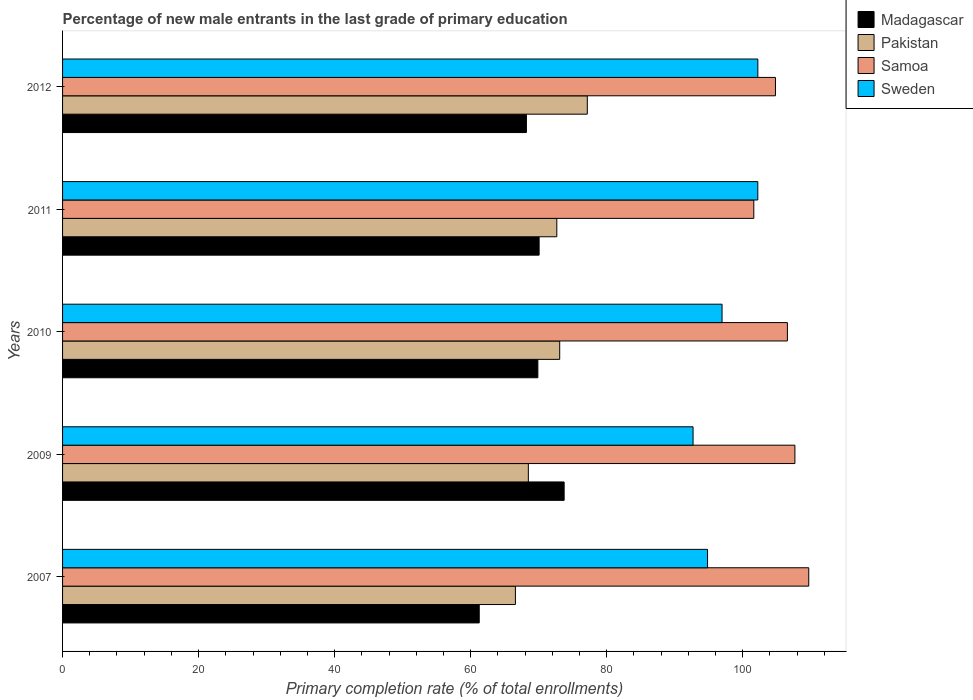How many different coloured bars are there?
Your answer should be compact. 4. How many groups of bars are there?
Ensure brevity in your answer.  5. Are the number of bars on each tick of the Y-axis equal?
Ensure brevity in your answer.  Yes. How many bars are there on the 2nd tick from the top?
Keep it short and to the point. 4. What is the percentage of new male entrants in Madagascar in 2011?
Offer a terse response. 70.07. Across all years, what is the maximum percentage of new male entrants in Pakistan?
Ensure brevity in your answer.  77.15. Across all years, what is the minimum percentage of new male entrants in Sweden?
Give a very brief answer. 92.7. In which year was the percentage of new male entrants in Madagascar maximum?
Your response must be concise. 2009. What is the total percentage of new male entrants in Sweden in the graph?
Your answer should be very brief. 488.94. What is the difference between the percentage of new male entrants in Madagascar in 2009 and that in 2011?
Ensure brevity in your answer.  3.68. What is the difference between the percentage of new male entrants in Sweden in 2010 and the percentage of new male entrants in Pakistan in 2009?
Ensure brevity in your answer.  28.48. What is the average percentage of new male entrants in Sweden per year?
Your answer should be compact. 97.79. In the year 2009, what is the difference between the percentage of new male entrants in Samoa and percentage of new male entrants in Sweden?
Your answer should be compact. 14.97. What is the ratio of the percentage of new male entrants in Samoa in 2007 to that in 2012?
Ensure brevity in your answer.  1.05. Is the difference between the percentage of new male entrants in Samoa in 2010 and 2011 greater than the difference between the percentage of new male entrants in Sweden in 2010 and 2011?
Your answer should be very brief. Yes. What is the difference between the highest and the second highest percentage of new male entrants in Sweden?
Give a very brief answer. 0.01. What is the difference between the highest and the lowest percentage of new male entrants in Pakistan?
Provide a short and direct response. 10.57. In how many years, is the percentage of new male entrants in Pakistan greater than the average percentage of new male entrants in Pakistan taken over all years?
Your answer should be very brief. 3. What does the 4th bar from the top in 2010 represents?
Your answer should be very brief. Madagascar. What does the 4th bar from the bottom in 2007 represents?
Give a very brief answer. Sweden. Is it the case that in every year, the sum of the percentage of new male entrants in Madagascar and percentage of new male entrants in Pakistan is greater than the percentage of new male entrants in Samoa?
Ensure brevity in your answer.  Yes. How many bars are there?
Your response must be concise. 20. What is the difference between two consecutive major ticks on the X-axis?
Keep it short and to the point. 20. Does the graph contain grids?
Keep it short and to the point. No. What is the title of the graph?
Provide a succinct answer. Percentage of new male entrants in the last grade of primary education. What is the label or title of the X-axis?
Provide a succinct answer. Primary completion rate (% of total enrollments). What is the label or title of the Y-axis?
Give a very brief answer. Years. What is the Primary completion rate (% of total enrollments) in Madagascar in 2007?
Your response must be concise. 61.26. What is the Primary completion rate (% of total enrollments) in Pakistan in 2007?
Provide a short and direct response. 66.58. What is the Primary completion rate (% of total enrollments) of Samoa in 2007?
Your response must be concise. 109.71. What is the Primary completion rate (% of total enrollments) of Sweden in 2007?
Your answer should be compact. 94.83. What is the Primary completion rate (% of total enrollments) in Madagascar in 2009?
Keep it short and to the point. 73.75. What is the Primary completion rate (% of total enrollments) in Pakistan in 2009?
Provide a short and direct response. 68.48. What is the Primary completion rate (% of total enrollments) of Samoa in 2009?
Ensure brevity in your answer.  107.68. What is the Primary completion rate (% of total enrollments) of Sweden in 2009?
Make the answer very short. 92.7. What is the Primary completion rate (% of total enrollments) of Madagascar in 2010?
Provide a succinct answer. 69.88. What is the Primary completion rate (% of total enrollments) in Pakistan in 2010?
Give a very brief answer. 73.09. What is the Primary completion rate (% of total enrollments) in Samoa in 2010?
Make the answer very short. 106.57. What is the Primary completion rate (% of total enrollments) of Sweden in 2010?
Offer a very short reply. 96.96. What is the Primary completion rate (% of total enrollments) in Madagascar in 2011?
Make the answer very short. 70.07. What is the Primary completion rate (% of total enrollments) of Pakistan in 2011?
Make the answer very short. 72.67. What is the Primary completion rate (% of total enrollments) of Samoa in 2011?
Keep it short and to the point. 101.63. What is the Primary completion rate (% of total enrollments) of Sweden in 2011?
Your answer should be compact. 102.22. What is the Primary completion rate (% of total enrollments) of Madagascar in 2012?
Your answer should be compact. 68.2. What is the Primary completion rate (% of total enrollments) in Pakistan in 2012?
Ensure brevity in your answer.  77.15. What is the Primary completion rate (% of total enrollments) of Samoa in 2012?
Keep it short and to the point. 104.82. What is the Primary completion rate (% of total enrollments) in Sweden in 2012?
Offer a terse response. 102.23. Across all years, what is the maximum Primary completion rate (% of total enrollments) in Madagascar?
Your answer should be very brief. 73.75. Across all years, what is the maximum Primary completion rate (% of total enrollments) of Pakistan?
Ensure brevity in your answer.  77.15. Across all years, what is the maximum Primary completion rate (% of total enrollments) in Samoa?
Make the answer very short. 109.71. Across all years, what is the maximum Primary completion rate (% of total enrollments) of Sweden?
Your answer should be compact. 102.23. Across all years, what is the minimum Primary completion rate (% of total enrollments) in Madagascar?
Your answer should be very brief. 61.26. Across all years, what is the minimum Primary completion rate (% of total enrollments) of Pakistan?
Make the answer very short. 66.58. Across all years, what is the minimum Primary completion rate (% of total enrollments) in Samoa?
Offer a very short reply. 101.63. Across all years, what is the minimum Primary completion rate (% of total enrollments) of Sweden?
Offer a terse response. 92.7. What is the total Primary completion rate (% of total enrollments) in Madagascar in the graph?
Your answer should be compact. 343.16. What is the total Primary completion rate (% of total enrollments) of Pakistan in the graph?
Give a very brief answer. 357.97. What is the total Primary completion rate (% of total enrollments) in Samoa in the graph?
Your response must be concise. 530.4. What is the total Primary completion rate (% of total enrollments) in Sweden in the graph?
Provide a succinct answer. 488.94. What is the difference between the Primary completion rate (% of total enrollments) of Madagascar in 2007 and that in 2009?
Make the answer very short. -12.48. What is the difference between the Primary completion rate (% of total enrollments) of Pakistan in 2007 and that in 2009?
Offer a terse response. -1.9. What is the difference between the Primary completion rate (% of total enrollments) of Samoa in 2007 and that in 2009?
Your response must be concise. 2.03. What is the difference between the Primary completion rate (% of total enrollments) in Sweden in 2007 and that in 2009?
Make the answer very short. 2.13. What is the difference between the Primary completion rate (% of total enrollments) of Madagascar in 2007 and that in 2010?
Give a very brief answer. -8.62. What is the difference between the Primary completion rate (% of total enrollments) of Pakistan in 2007 and that in 2010?
Offer a very short reply. -6.51. What is the difference between the Primary completion rate (% of total enrollments) in Samoa in 2007 and that in 2010?
Your response must be concise. 3.14. What is the difference between the Primary completion rate (% of total enrollments) in Sweden in 2007 and that in 2010?
Keep it short and to the point. -2.13. What is the difference between the Primary completion rate (% of total enrollments) in Madagascar in 2007 and that in 2011?
Give a very brief answer. -8.8. What is the difference between the Primary completion rate (% of total enrollments) in Pakistan in 2007 and that in 2011?
Your answer should be compact. -6.09. What is the difference between the Primary completion rate (% of total enrollments) in Samoa in 2007 and that in 2011?
Provide a succinct answer. 8.08. What is the difference between the Primary completion rate (% of total enrollments) in Sweden in 2007 and that in 2011?
Your response must be concise. -7.39. What is the difference between the Primary completion rate (% of total enrollments) in Madagascar in 2007 and that in 2012?
Ensure brevity in your answer.  -6.94. What is the difference between the Primary completion rate (% of total enrollments) of Pakistan in 2007 and that in 2012?
Offer a very short reply. -10.57. What is the difference between the Primary completion rate (% of total enrollments) in Samoa in 2007 and that in 2012?
Offer a terse response. 4.89. What is the difference between the Primary completion rate (% of total enrollments) of Sweden in 2007 and that in 2012?
Offer a terse response. -7.4. What is the difference between the Primary completion rate (% of total enrollments) of Madagascar in 2009 and that in 2010?
Your answer should be compact. 3.87. What is the difference between the Primary completion rate (% of total enrollments) of Pakistan in 2009 and that in 2010?
Ensure brevity in your answer.  -4.61. What is the difference between the Primary completion rate (% of total enrollments) in Samoa in 2009 and that in 2010?
Your answer should be very brief. 1.1. What is the difference between the Primary completion rate (% of total enrollments) of Sweden in 2009 and that in 2010?
Provide a succinct answer. -4.26. What is the difference between the Primary completion rate (% of total enrollments) of Madagascar in 2009 and that in 2011?
Your answer should be very brief. 3.68. What is the difference between the Primary completion rate (% of total enrollments) of Pakistan in 2009 and that in 2011?
Provide a short and direct response. -4.18. What is the difference between the Primary completion rate (% of total enrollments) of Samoa in 2009 and that in 2011?
Offer a very short reply. 6.05. What is the difference between the Primary completion rate (% of total enrollments) of Sweden in 2009 and that in 2011?
Keep it short and to the point. -9.52. What is the difference between the Primary completion rate (% of total enrollments) of Madagascar in 2009 and that in 2012?
Provide a short and direct response. 5.55. What is the difference between the Primary completion rate (% of total enrollments) of Pakistan in 2009 and that in 2012?
Provide a short and direct response. -8.67. What is the difference between the Primary completion rate (% of total enrollments) of Samoa in 2009 and that in 2012?
Your answer should be very brief. 2.86. What is the difference between the Primary completion rate (% of total enrollments) in Sweden in 2009 and that in 2012?
Keep it short and to the point. -9.52. What is the difference between the Primary completion rate (% of total enrollments) of Madagascar in 2010 and that in 2011?
Provide a succinct answer. -0.19. What is the difference between the Primary completion rate (% of total enrollments) in Pakistan in 2010 and that in 2011?
Your response must be concise. 0.43. What is the difference between the Primary completion rate (% of total enrollments) in Samoa in 2010 and that in 2011?
Your answer should be very brief. 4.94. What is the difference between the Primary completion rate (% of total enrollments) of Sweden in 2010 and that in 2011?
Keep it short and to the point. -5.26. What is the difference between the Primary completion rate (% of total enrollments) in Madagascar in 2010 and that in 2012?
Offer a very short reply. 1.68. What is the difference between the Primary completion rate (% of total enrollments) of Pakistan in 2010 and that in 2012?
Provide a short and direct response. -4.06. What is the difference between the Primary completion rate (% of total enrollments) in Samoa in 2010 and that in 2012?
Your response must be concise. 1.76. What is the difference between the Primary completion rate (% of total enrollments) in Sweden in 2010 and that in 2012?
Your answer should be compact. -5.26. What is the difference between the Primary completion rate (% of total enrollments) of Madagascar in 2011 and that in 2012?
Give a very brief answer. 1.87. What is the difference between the Primary completion rate (% of total enrollments) in Pakistan in 2011 and that in 2012?
Your answer should be compact. -4.48. What is the difference between the Primary completion rate (% of total enrollments) of Samoa in 2011 and that in 2012?
Provide a short and direct response. -3.18. What is the difference between the Primary completion rate (% of total enrollments) in Sweden in 2011 and that in 2012?
Your answer should be compact. -0.01. What is the difference between the Primary completion rate (% of total enrollments) in Madagascar in 2007 and the Primary completion rate (% of total enrollments) in Pakistan in 2009?
Provide a succinct answer. -7.22. What is the difference between the Primary completion rate (% of total enrollments) of Madagascar in 2007 and the Primary completion rate (% of total enrollments) of Samoa in 2009?
Ensure brevity in your answer.  -46.41. What is the difference between the Primary completion rate (% of total enrollments) of Madagascar in 2007 and the Primary completion rate (% of total enrollments) of Sweden in 2009?
Offer a very short reply. -31.44. What is the difference between the Primary completion rate (% of total enrollments) in Pakistan in 2007 and the Primary completion rate (% of total enrollments) in Samoa in 2009?
Give a very brief answer. -41.1. What is the difference between the Primary completion rate (% of total enrollments) of Pakistan in 2007 and the Primary completion rate (% of total enrollments) of Sweden in 2009?
Provide a short and direct response. -26.12. What is the difference between the Primary completion rate (% of total enrollments) of Samoa in 2007 and the Primary completion rate (% of total enrollments) of Sweden in 2009?
Your answer should be compact. 17.01. What is the difference between the Primary completion rate (% of total enrollments) of Madagascar in 2007 and the Primary completion rate (% of total enrollments) of Pakistan in 2010?
Give a very brief answer. -11.83. What is the difference between the Primary completion rate (% of total enrollments) of Madagascar in 2007 and the Primary completion rate (% of total enrollments) of Samoa in 2010?
Provide a succinct answer. -45.31. What is the difference between the Primary completion rate (% of total enrollments) in Madagascar in 2007 and the Primary completion rate (% of total enrollments) in Sweden in 2010?
Your answer should be compact. -35.7. What is the difference between the Primary completion rate (% of total enrollments) in Pakistan in 2007 and the Primary completion rate (% of total enrollments) in Samoa in 2010?
Provide a short and direct response. -39.99. What is the difference between the Primary completion rate (% of total enrollments) in Pakistan in 2007 and the Primary completion rate (% of total enrollments) in Sweden in 2010?
Keep it short and to the point. -30.38. What is the difference between the Primary completion rate (% of total enrollments) in Samoa in 2007 and the Primary completion rate (% of total enrollments) in Sweden in 2010?
Provide a short and direct response. 12.75. What is the difference between the Primary completion rate (% of total enrollments) in Madagascar in 2007 and the Primary completion rate (% of total enrollments) in Pakistan in 2011?
Your answer should be very brief. -11.41. What is the difference between the Primary completion rate (% of total enrollments) in Madagascar in 2007 and the Primary completion rate (% of total enrollments) in Samoa in 2011?
Provide a short and direct response. -40.37. What is the difference between the Primary completion rate (% of total enrollments) in Madagascar in 2007 and the Primary completion rate (% of total enrollments) in Sweden in 2011?
Your response must be concise. -40.96. What is the difference between the Primary completion rate (% of total enrollments) in Pakistan in 2007 and the Primary completion rate (% of total enrollments) in Samoa in 2011?
Give a very brief answer. -35.05. What is the difference between the Primary completion rate (% of total enrollments) in Pakistan in 2007 and the Primary completion rate (% of total enrollments) in Sweden in 2011?
Your response must be concise. -35.64. What is the difference between the Primary completion rate (% of total enrollments) of Samoa in 2007 and the Primary completion rate (% of total enrollments) of Sweden in 2011?
Ensure brevity in your answer.  7.49. What is the difference between the Primary completion rate (% of total enrollments) in Madagascar in 2007 and the Primary completion rate (% of total enrollments) in Pakistan in 2012?
Your answer should be compact. -15.89. What is the difference between the Primary completion rate (% of total enrollments) in Madagascar in 2007 and the Primary completion rate (% of total enrollments) in Samoa in 2012?
Offer a very short reply. -43.55. What is the difference between the Primary completion rate (% of total enrollments) of Madagascar in 2007 and the Primary completion rate (% of total enrollments) of Sweden in 2012?
Provide a short and direct response. -40.96. What is the difference between the Primary completion rate (% of total enrollments) of Pakistan in 2007 and the Primary completion rate (% of total enrollments) of Samoa in 2012?
Keep it short and to the point. -38.23. What is the difference between the Primary completion rate (% of total enrollments) in Pakistan in 2007 and the Primary completion rate (% of total enrollments) in Sweden in 2012?
Keep it short and to the point. -35.65. What is the difference between the Primary completion rate (% of total enrollments) in Samoa in 2007 and the Primary completion rate (% of total enrollments) in Sweden in 2012?
Your response must be concise. 7.48. What is the difference between the Primary completion rate (% of total enrollments) in Madagascar in 2009 and the Primary completion rate (% of total enrollments) in Pakistan in 2010?
Provide a short and direct response. 0.65. What is the difference between the Primary completion rate (% of total enrollments) in Madagascar in 2009 and the Primary completion rate (% of total enrollments) in Samoa in 2010?
Give a very brief answer. -32.83. What is the difference between the Primary completion rate (% of total enrollments) in Madagascar in 2009 and the Primary completion rate (% of total enrollments) in Sweden in 2010?
Give a very brief answer. -23.22. What is the difference between the Primary completion rate (% of total enrollments) in Pakistan in 2009 and the Primary completion rate (% of total enrollments) in Samoa in 2010?
Ensure brevity in your answer.  -38.09. What is the difference between the Primary completion rate (% of total enrollments) of Pakistan in 2009 and the Primary completion rate (% of total enrollments) of Sweden in 2010?
Offer a very short reply. -28.48. What is the difference between the Primary completion rate (% of total enrollments) in Samoa in 2009 and the Primary completion rate (% of total enrollments) in Sweden in 2010?
Ensure brevity in your answer.  10.71. What is the difference between the Primary completion rate (% of total enrollments) in Madagascar in 2009 and the Primary completion rate (% of total enrollments) in Pakistan in 2011?
Your answer should be compact. 1.08. What is the difference between the Primary completion rate (% of total enrollments) of Madagascar in 2009 and the Primary completion rate (% of total enrollments) of Samoa in 2011?
Make the answer very short. -27.88. What is the difference between the Primary completion rate (% of total enrollments) of Madagascar in 2009 and the Primary completion rate (% of total enrollments) of Sweden in 2011?
Offer a very short reply. -28.47. What is the difference between the Primary completion rate (% of total enrollments) in Pakistan in 2009 and the Primary completion rate (% of total enrollments) in Samoa in 2011?
Keep it short and to the point. -33.15. What is the difference between the Primary completion rate (% of total enrollments) in Pakistan in 2009 and the Primary completion rate (% of total enrollments) in Sweden in 2011?
Ensure brevity in your answer.  -33.74. What is the difference between the Primary completion rate (% of total enrollments) of Samoa in 2009 and the Primary completion rate (% of total enrollments) of Sweden in 2011?
Ensure brevity in your answer.  5.46. What is the difference between the Primary completion rate (% of total enrollments) of Madagascar in 2009 and the Primary completion rate (% of total enrollments) of Pakistan in 2012?
Offer a very short reply. -3.4. What is the difference between the Primary completion rate (% of total enrollments) of Madagascar in 2009 and the Primary completion rate (% of total enrollments) of Samoa in 2012?
Offer a terse response. -31.07. What is the difference between the Primary completion rate (% of total enrollments) in Madagascar in 2009 and the Primary completion rate (% of total enrollments) in Sweden in 2012?
Provide a succinct answer. -28.48. What is the difference between the Primary completion rate (% of total enrollments) of Pakistan in 2009 and the Primary completion rate (% of total enrollments) of Samoa in 2012?
Keep it short and to the point. -36.33. What is the difference between the Primary completion rate (% of total enrollments) in Pakistan in 2009 and the Primary completion rate (% of total enrollments) in Sweden in 2012?
Ensure brevity in your answer.  -33.74. What is the difference between the Primary completion rate (% of total enrollments) of Samoa in 2009 and the Primary completion rate (% of total enrollments) of Sweden in 2012?
Offer a very short reply. 5.45. What is the difference between the Primary completion rate (% of total enrollments) in Madagascar in 2010 and the Primary completion rate (% of total enrollments) in Pakistan in 2011?
Make the answer very short. -2.79. What is the difference between the Primary completion rate (% of total enrollments) in Madagascar in 2010 and the Primary completion rate (% of total enrollments) in Samoa in 2011?
Provide a succinct answer. -31.75. What is the difference between the Primary completion rate (% of total enrollments) in Madagascar in 2010 and the Primary completion rate (% of total enrollments) in Sweden in 2011?
Give a very brief answer. -32.34. What is the difference between the Primary completion rate (% of total enrollments) in Pakistan in 2010 and the Primary completion rate (% of total enrollments) in Samoa in 2011?
Provide a succinct answer. -28.54. What is the difference between the Primary completion rate (% of total enrollments) of Pakistan in 2010 and the Primary completion rate (% of total enrollments) of Sweden in 2011?
Your answer should be very brief. -29.13. What is the difference between the Primary completion rate (% of total enrollments) of Samoa in 2010 and the Primary completion rate (% of total enrollments) of Sweden in 2011?
Your response must be concise. 4.35. What is the difference between the Primary completion rate (% of total enrollments) in Madagascar in 2010 and the Primary completion rate (% of total enrollments) in Pakistan in 2012?
Your answer should be compact. -7.27. What is the difference between the Primary completion rate (% of total enrollments) of Madagascar in 2010 and the Primary completion rate (% of total enrollments) of Samoa in 2012?
Your response must be concise. -34.93. What is the difference between the Primary completion rate (% of total enrollments) of Madagascar in 2010 and the Primary completion rate (% of total enrollments) of Sweden in 2012?
Offer a terse response. -32.35. What is the difference between the Primary completion rate (% of total enrollments) in Pakistan in 2010 and the Primary completion rate (% of total enrollments) in Samoa in 2012?
Keep it short and to the point. -31.72. What is the difference between the Primary completion rate (% of total enrollments) of Pakistan in 2010 and the Primary completion rate (% of total enrollments) of Sweden in 2012?
Your answer should be compact. -29.13. What is the difference between the Primary completion rate (% of total enrollments) in Samoa in 2010 and the Primary completion rate (% of total enrollments) in Sweden in 2012?
Provide a short and direct response. 4.35. What is the difference between the Primary completion rate (% of total enrollments) in Madagascar in 2011 and the Primary completion rate (% of total enrollments) in Pakistan in 2012?
Provide a succinct answer. -7.08. What is the difference between the Primary completion rate (% of total enrollments) of Madagascar in 2011 and the Primary completion rate (% of total enrollments) of Samoa in 2012?
Ensure brevity in your answer.  -34.75. What is the difference between the Primary completion rate (% of total enrollments) of Madagascar in 2011 and the Primary completion rate (% of total enrollments) of Sweden in 2012?
Give a very brief answer. -32.16. What is the difference between the Primary completion rate (% of total enrollments) of Pakistan in 2011 and the Primary completion rate (% of total enrollments) of Samoa in 2012?
Provide a short and direct response. -32.15. What is the difference between the Primary completion rate (% of total enrollments) in Pakistan in 2011 and the Primary completion rate (% of total enrollments) in Sweden in 2012?
Ensure brevity in your answer.  -29.56. What is the difference between the Primary completion rate (% of total enrollments) of Samoa in 2011 and the Primary completion rate (% of total enrollments) of Sweden in 2012?
Give a very brief answer. -0.6. What is the average Primary completion rate (% of total enrollments) of Madagascar per year?
Your answer should be very brief. 68.63. What is the average Primary completion rate (% of total enrollments) of Pakistan per year?
Make the answer very short. 71.59. What is the average Primary completion rate (% of total enrollments) in Samoa per year?
Give a very brief answer. 106.08. What is the average Primary completion rate (% of total enrollments) in Sweden per year?
Provide a succinct answer. 97.79. In the year 2007, what is the difference between the Primary completion rate (% of total enrollments) in Madagascar and Primary completion rate (% of total enrollments) in Pakistan?
Make the answer very short. -5.32. In the year 2007, what is the difference between the Primary completion rate (% of total enrollments) of Madagascar and Primary completion rate (% of total enrollments) of Samoa?
Give a very brief answer. -48.45. In the year 2007, what is the difference between the Primary completion rate (% of total enrollments) of Madagascar and Primary completion rate (% of total enrollments) of Sweden?
Your answer should be very brief. -33.57. In the year 2007, what is the difference between the Primary completion rate (% of total enrollments) in Pakistan and Primary completion rate (% of total enrollments) in Samoa?
Your answer should be compact. -43.13. In the year 2007, what is the difference between the Primary completion rate (% of total enrollments) of Pakistan and Primary completion rate (% of total enrollments) of Sweden?
Give a very brief answer. -28.25. In the year 2007, what is the difference between the Primary completion rate (% of total enrollments) in Samoa and Primary completion rate (% of total enrollments) in Sweden?
Provide a succinct answer. 14.88. In the year 2009, what is the difference between the Primary completion rate (% of total enrollments) of Madagascar and Primary completion rate (% of total enrollments) of Pakistan?
Make the answer very short. 5.26. In the year 2009, what is the difference between the Primary completion rate (% of total enrollments) in Madagascar and Primary completion rate (% of total enrollments) in Samoa?
Keep it short and to the point. -33.93. In the year 2009, what is the difference between the Primary completion rate (% of total enrollments) in Madagascar and Primary completion rate (% of total enrollments) in Sweden?
Make the answer very short. -18.96. In the year 2009, what is the difference between the Primary completion rate (% of total enrollments) of Pakistan and Primary completion rate (% of total enrollments) of Samoa?
Provide a succinct answer. -39.19. In the year 2009, what is the difference between the Primary completion rate (% of total enrollments) in Pakistan and Primary completion rate (% of total enrollments) in Sweden?
Make the answer very short. -24.22. In the year 2009, what is the difference between the Primary completion rate (% of total enrollments) in Samoa and Primary completion rate (% of total enrollments) in Sweden?
Offer a very short reply. 14.97. In the year 2010, what is the difference between the Primary completion rate (% of total enrollments) of Madagascar and Primary completion rate (% of total enrollments) of Pakistan?
Make the answer very short. -3.21. In the year 2010, what is the difference between the Primary completion rate (% of total enrollments) in Madagascar and Primary completion rate (% of total enrollments) in Samoa?
Provide a succinct answer. -36.69. In the year 2010, what is the difference between the Primary completion rate (% of total enrollments) of Madagascar and Primary completion rate (% of total enrollments) of Sweden?
Give a very brief answer. -27.08. In the year 2010, what is the difference between the Primary completion rate (% of total enrollments) of Pakistan and Primary completion rate (% of total enrollments) of Samoa?
Provide a short and direct response. -33.48. In the year 2010, what is the difference between the Primary completion rate (% of total enrollments) of Pakistan and Primary completion rate (% of total enrollments) of Sweden?
Make the answer very short. -23.87. In the year 2010, what is the difference between the Primary completion rate (% of total enrollments) in Samoa and Primary completion rate (% of total enrollments) in Sweden?
Keep it short and to the point. 9.61. In the year 2011, what is the difference between the Primary completion rate (% of total enrollments) of Madagascar and Primary completion rate (% of total enrollments) of Pakistan?
Your answer should be very brief. -2.6. In the year 2011, what is the difference between the Primary completion rate (% of total enrollments) of Madagascar and Primary completion rate (% of total enrollments) of Samoa?
Offer a terse response. -31.56. In the year 2011, what is the difference between the Primary completion rate (% of total enrollments) of Madagascar and Primary completion rate (% of total enrollments) of Sweden?
Your response must be concise. -32.15. In the year 2011, what is the difference between the Primary completion rate (% of total enrollments) in Pakistan and Primary completion rate (% of total enrollments) in Samoa?
Ensure brevity in your answer.  -28.96. In the year 2011, what is the difference between the Primary completion rate (% of total enrollments) in Pakistan and Primary completion rate (% of total enrollments) in Sweden?
Your answer should be compact. -29.55. In the year 2011, what is the difference between the Primary completion rate (% of total enrollments) of Samoa and Primary completion rate (% of total enrollments) of Sweden?
Ensure brevity in your answer.  -0.59. In the year 2012, what is the difference between the Primary completion rate (% of total enrollments) in Madagascar and Primary completion rate (% of total enrollments) in Pakistan?
Keep it short and to the point. -8.95. In the year 2012, what is the difference between the Primary completion rate (% of total enrollments) of Madagascar and Primary completion rate (% of total enrollments) of Samoa?
Give a very brief answer. -36.61. In the year 2012, what is the difference between the Primary completion rate (% of total enrollments) in Madagascar and Primary completion rate (% of total enrollments) in Sweden?
Ensure brevity in your answer.  -34.03. In the year 2012, what is the difference between the Primary completion rate (% of total enrollments) in Pakistan and Primary completion rate (% of total enrollments) in Samoa?
Keep it short and to the point. -27.66. In the year 2012, what is the difference between the Primary completion rate (% of total enrollments) of Pakistan and Primary completion rate (% of total enrollments) of Sweden?
Offer a terse response. -25.08. In the year 2012, what is the difference between the Primary completion rate (% of total enrollments) in Samoa and Primary completion rate (% of total enrollments) in Sweden?
Your answer should be compact. 2.59. What is the ratio of the Primary completion rate (% of total enrollments) in Madagascar in 2007 to that in 2009?
Your answer should be very brief. 0.83. What is the ratio of the Primary completion rate (% of total enrollments) in Pakistan in 2007 to that in 2009?
Provide a succinct answer. 0.97. What is the ratio of the Primary completion rate (% of total enrollments) in Samoa in 2007 to that in 2009?
Offer a very short reply. 1.02. What is the ratio of the Primary completion rate (% of total enrollments) of Madagascar in 2007 to that in 2010?
Keep it short and to the point. 0.88. What is the ratio of the Primary completion rate (% of total enrollments) in Pakistan in 2007 to that in 2010?
Your response must be concise. 0.91. What is the ratio of the Primary completion rate (% of total enrollments) in Samoa in 2007 to that in 2010?
Make the answer very short. 1.03. What is the ratio of the Primary completion rate (% of total enrollments) of Madagascar in 2007 to that in 2011?
Your answer should be very brief. 0.87. What is the ratio of the Primary completion rate (% of total enrollments) in Pakistan in 2007 to that in 2011?
Provide a short and direct response. 0.92. What is the ratio of the Primary completion rate (% of total enrollments) of Samoa in 2007 to that in 2011?
Provide a succinct answer. 1.08. What is the ratio of the Primary completion rate (% of total enrollments) in Sweden in 2007 to that in 2011?
Offer a very short reply. 0.93. What is the ratio of the Primary completion rate (% of total enrollments) of Madagascar in 2007 to that in 2012?
Your response must be concise. 0.9. What is the ratio of the Primary completion rate (% of total enrollments) in Pakistan in 2007 to that in 2012?
Your answer should be very brief. 0.86. What is the ratio of the Primary completion rate (% of total enrollments) of Samoa in 2007 to that in 2012?
Ensure brevity in your answer.  1.05. What is the ratio of the Primary completion rate (% of total enrollments) in Sweden in 2007 to that in 2012?
Provide a succinct answer. 0.93. What is the ratio of the Primary completion rate (% of total enrollments) in Madagascar in 2009 to that in 2010?
Your response must be concise. 1.06. What is the ratio of the Primary completion rate (% of total enrollments) of Pakistan in 2009 to that in 2010?
Keep it short and to the point. 0.94. What is the ratio of the Primary completion rate (% of total enrollments) in Samoa in 2009 to that in 2010?
Your answer should be compact. 1.01. What is the ratio of the Primary completion rate (% of total enrollments) of Sweden in 2009 to that in 2010?
Provide a short and direct response. 0.96. What is the ratio of the Primary completion rate (% of total enrollments) of Madagascar in 2009 to that in 2011?
Your answer should be very brief. 1.05. What is the ratio of the Primary completion rate (% of total enrollments) of Pakistan in 2009 to that in 2011?
Your answer should be compact. 0.94. What is the ratio of the Primary completion rate (% of total enrollments) of Samoa in 2009 to that in 2011?
Offer a very short reply. 1.06. What is the ratio of the Primary completion rate (% of total enrollments) in Sweden in 2009 to that in 2011?
Ensure brevity in your answer.  0.91. What is the ratio of the Primary completion rate (% of total enrollments) of Madagascar in 2009 to that in 2012?
Provide a succinct answer. 1.08. What is the ratio of the Primary completion rate (% of total enrollments) in Pakistan in 2009 to that in 2012?
Make the answer very short. 0.89. What is the ratio of the Primary completion rate (% of total enrollments) of Samoa in 2009 to that in 2012?
Make the answer very short. 1.03. What is the ratio of the Primary completion rate (% of total enrollments) of Sweden in 2009 to that in 2012?
Provide a short and direct response. 0.91. What is the ratio of the Primary completion rate (% of total enrollments) of Pakistan in 2010 to that in 2011?
Provide a succinct answer. 1.01. What is the ratio of the Primary completion rate (% of total enrollments) of Samoa in 2010 to that in 2011?
Your answer should be compact. 1.05. What is the ratio of the Primary completion rate (% of total enrollments) of Sweden in 2010 to that in 2011?
Your response must be concise. 0.95. What is the ratio of the Primary completion rate (% of total enrollments) in Madagascar in 2010 to that in 2012?
Offer a very short reply. 1.02. What is the ratio of the Primary completion rate (% of total enrollments) in Samoa in 2010 to that in 2012?
Keep it short and to the point. 1.02. What is the ratio of the Primary completion rate (% of total enrollments) in Sweden in 2010 to that in 2012?
Your response must be concise. 0.95. What is the ratio of the Primary completion rate (% of total enrollments) in Madagascar in 2011 to that in 2012?
Make the answer very short. 1.03. What is the ratio of the Primary completion rate (% of total enrollments) of Pakistan in 2011 to that in 2012?
Give a very brief answer. 0.94. What is the ratio of the Primary completion rate (% of total enrollments) in Samoa in 2011 to that in 2012?
Provide a short and direct response. 0.97. What is the ratio of the Primary completion rate (% of total enrollments) in Sweden in 2011 to that in 2012?
Offer a very short reply. 1. What is the difference between the highest and the second highest Primary completion rate (% of total enrollments) in Madagascar?
Provide a succinct answer. 3.68. What is the difference between the highest and the second highest Primary completion rate (% of total enrollments) in Pakistan?
Offer a very short reply. 4.06. What is the difference between the highest and the second highest Primary completion rate (% of total enrollments) in Samoa?
Offer a terse response. 2.03. What is the difference between the highest and the second highest Primary completion rate (% of total enrollments) in Sweden?
Keep it short and to the point. 0.01. What is the difference between the highest and the lowest Primary completion rate (% of total enrollments) of Madagascar?
Make the answer very short. 12.48. What is the difference between the highest and the lowest Primary completion rate (% of total enrollments) of Pakistan?
Keep it short and to the point. 10.57. What is the difference between the highest and the lowest Primary completion rate (% of total enrollments) in Samoa?
Keep it short and to the point. 8.08. What is the difference between the highest and the lowest Primary completion rate (% of total enrollments) in Sweden?
Make the answer very short. 9.52. 